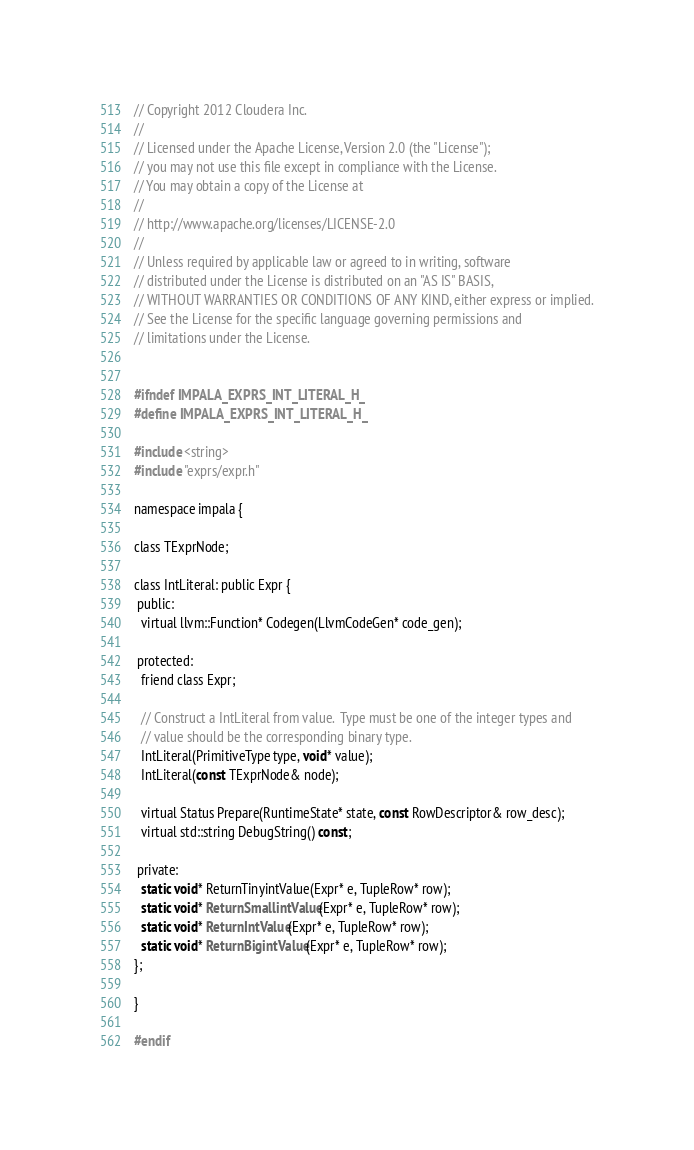Convert code to text. <code><loc_0><loc_0><loc_500><loc_500><_C_>// Copyright 2012 Cloudera Inc.
//
// Licensed under the Apache License, Version 2.0 (the "License");
// you may not use this file except in compliance with the License.
// You may obtain a copy of the License at
//
// http://www.apache.org/licenses/LICENSE-2.0
//
// Unless required by applicable law or agreed to in writing, software
// distributed under the License is distributed on an "AS IS" BASIS,
// WITHOUT WARRANTIES OR CONDITIONS OF ANY KIND, either express or implied.
// See the License for the specific language governing permissions and
// limitations under the License.


#ifndef IMPALA_EXPRS_INT_LITERAL_H_
#define IMPALA_EXPRS_INT_LITERAL_H_

#include <string>
#include "exprs/expr.h"

namespace impala {

class TExprNode;

class IntLiteral: public Expr {
 public:
  virtual llvm::Function* Codegen(LlvmCodeGen* code_gen);

 protected:
  friend class Expr;

  // Construct a IntLiteral from value.  Type must be one of the integer types and
  // value should be the corresponding binary type.  
  IntLiteral(PrimitiveType type, void* value);
  IntLiteral(const TExprNode& node);

  virtual Status Prepare(RuntimeState* state, const RowDescriptor& row_desc);
  virtual std::string DebugString() const;

 private:
  static void* ReturnTinyintValue(Expr* e, TupleRow* row);
  static void* ReturnSmallintValue(Expr* e, TupleRow* row);
  static void* ReturnIntValue(Expr* e, TupleRow* row);
  static void* ReturnBigintValue(Expr* e, TupleRow* row);
};

}

#endif
</code> 